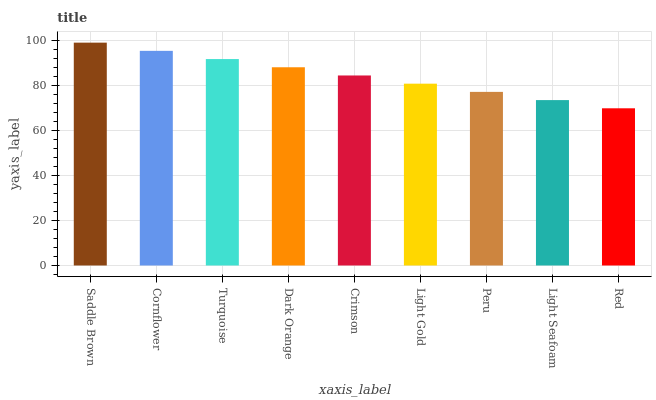Is Red the minimum?
Answer yes or no. Yes. Is Saddle Brown the maximum?
Answer yes or no. Yes. Is Cornflower the minimum?
Answer yes or no. No. Is Cornflower the maximum?
Answer yes or no. No. Is Saddle Brown greater than Cornflower?
Answer yes or no. Yes. Is Cornflower less than Saddle Brown?
Answer yes or no. Yes. Is Cornflower greater than Saddle Brown?
Answer yes or no. No. Is Saddle Brown less than Cornflower?
Answer yes or no. No. Is Crimson the high median?
Answer yes or no. Yes. Is Crimson the low median?
Answer yes or no. Yes. Is Light Gold the high median?
Answer yes or no. No. Is Peru the low median?
Answer yes or no. No. 